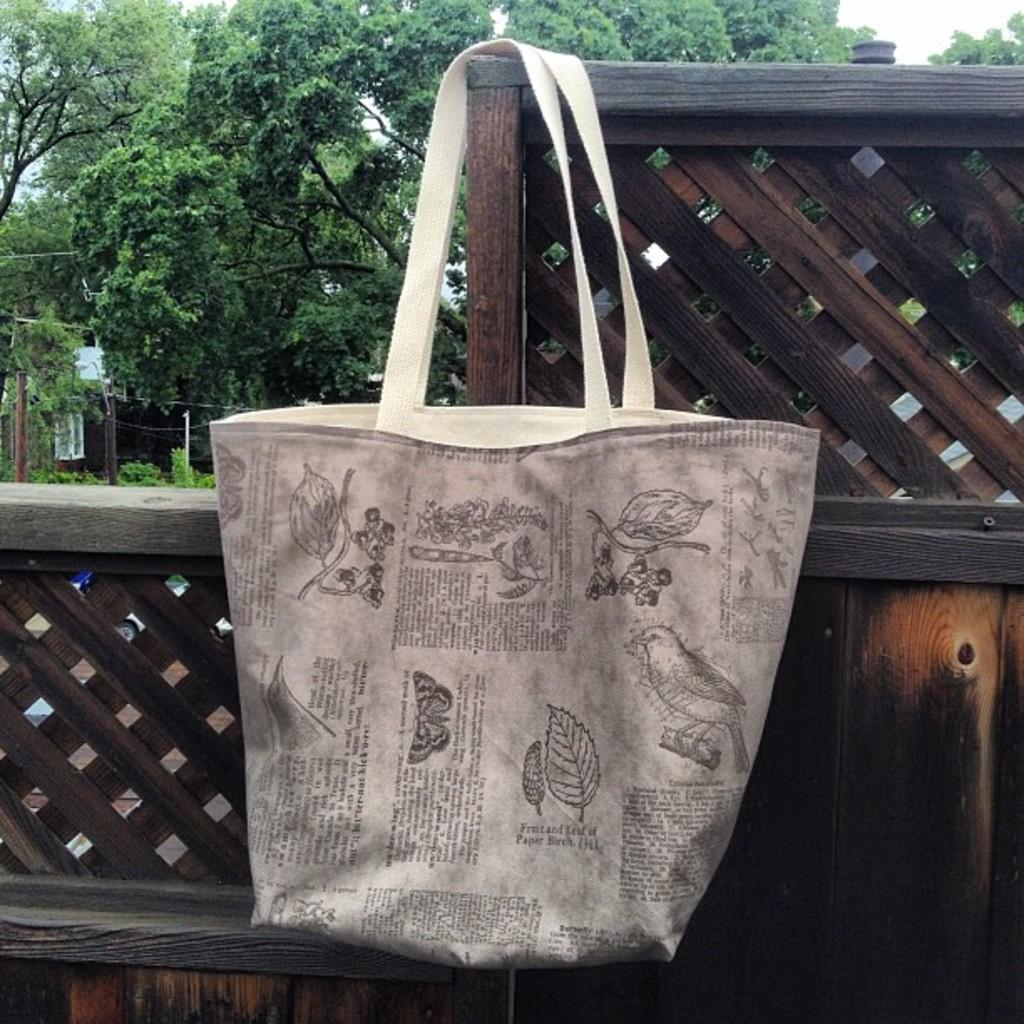What object is the main focus of the image? There is a bag in the image. How is the bag being emphasized in the image? The bag is highlighted. What can be seen in the distance in the image? There are trees in the background of the image. What is the income of the person who owns the bag in the image? There is no information about the income of the person who owns the bag in the image. Can you hear the bag crying in the image? Bags do not have the ability to cry, so there is no crying bag in the image. 